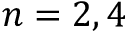<formula> <loc_0><loc_0><loc_500><loc_500>n = 2 , 4</formula> 